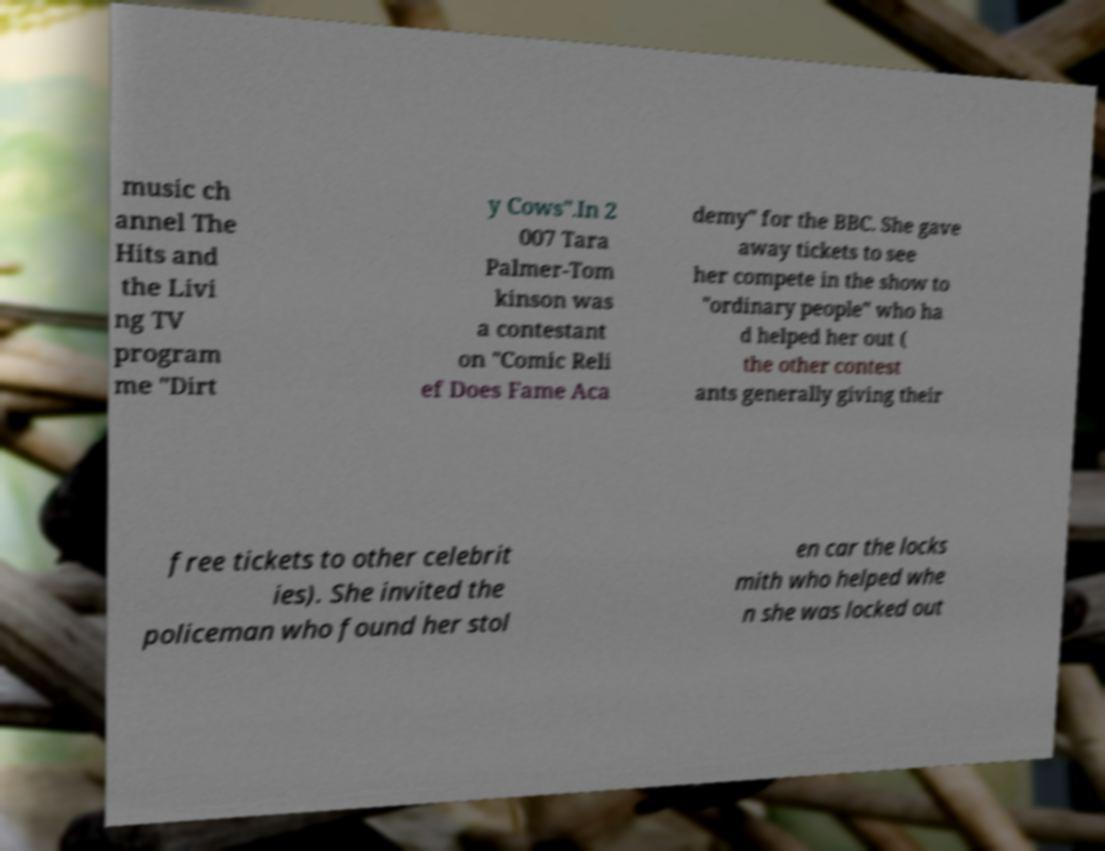For documentation purposes, I need the text within this image transcribed. Could you provide that? music ch annel The Hits and the Livi ng TV program me "Dirt y Cows".In 2 007 Tara Palmer-Tom kinson was a contestant on "Comic Reli ef Does Fame Aca demy" for the BBC. She gave away tickets to see her compete in the show to "ordinary people" who ha d helped her out ( the other contest ants generally giving their free tickets to other celebrit ies). She invited the policeman who found her stol en car the locks mith who helped whe n she was locked out 